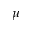<formula> <loc_0><loc_0><loc_500><loc_500>\mu</formula> 